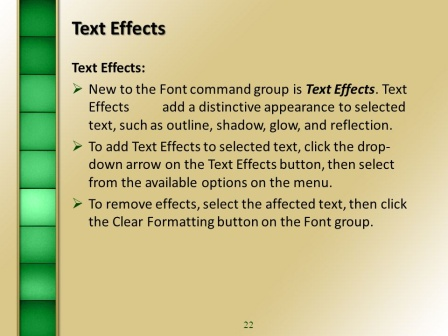Imagining that this slide were part of a fantasy world, what kind of magical presentation could it be a part of? In a fantasy world, this slide could be part of an ancient arcane scholar's lecture series on the 'Art of Enchanted Typography'. The 'Text Effects' might not merely modify the appearance of text but could actually imbue written words with magical properties. Outlines could make text glow with ethereal light, shadows might cast protective spells, and reflections could serve as portals to other dimensions. The green gradient bar symbolizes the flow of mana, illustrating how energy transitions through different planes. The number '22' marks it as a crucial step in a 100-slide compendium of ancient knowledge on how to craft scrolls and tomes of immense power. 